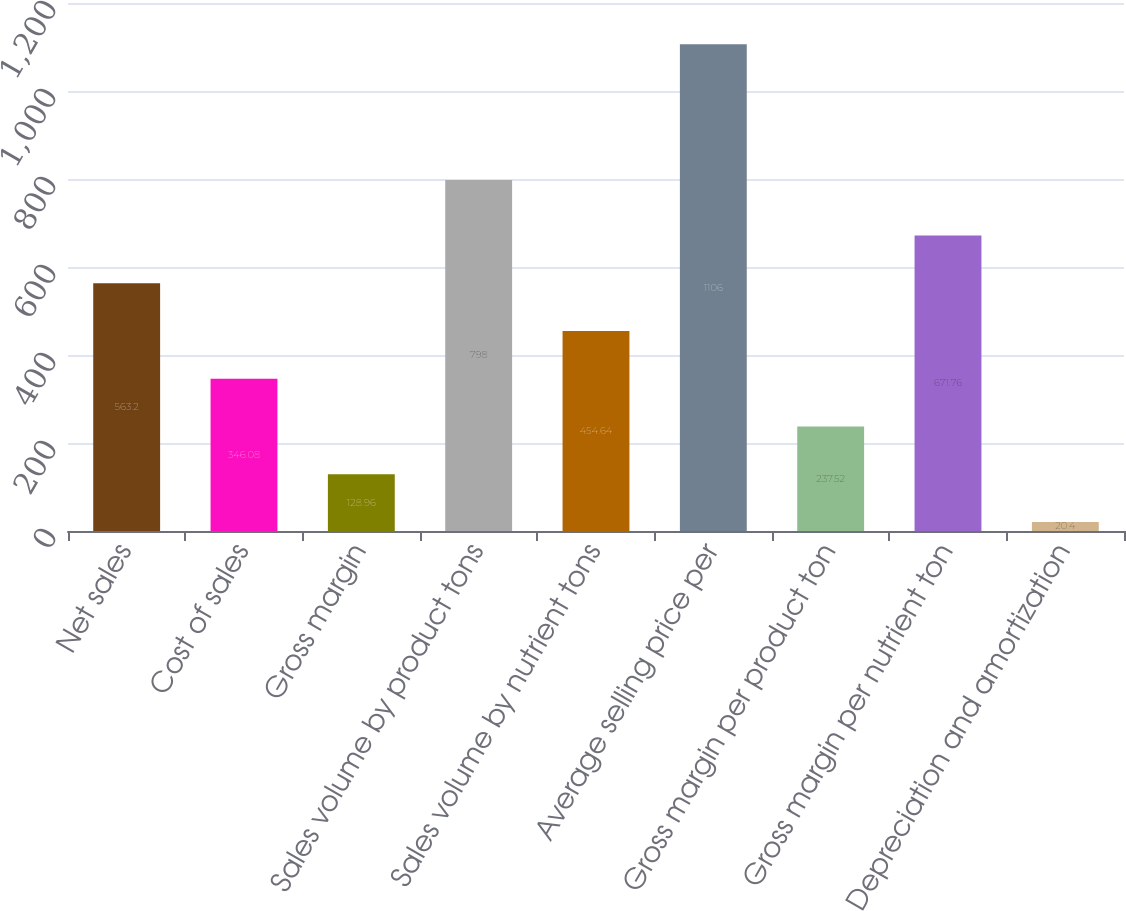Convert chart to OTSL. <chart><loc_0><loc_0><loc_500><loc_500><bar_chart><fcel>Net sales<fcel>Cost of sales<fcel>Gross margin<fcel>Sales volume by product tons<fcel>Sales volume by nutrient tons<fcel>Average selling price per<fcel>Gross margin per product ton<fcel>Gross margin per nutrient ton<fcel>Depreciation and amortization<nl><fcel>563.2<fcel>346.08<fcel>128.96<fcel>798<fcel>454.64<fcel>1106<fcel>237.52<fcel>671.76<fcel>20.4<nl></chart> 